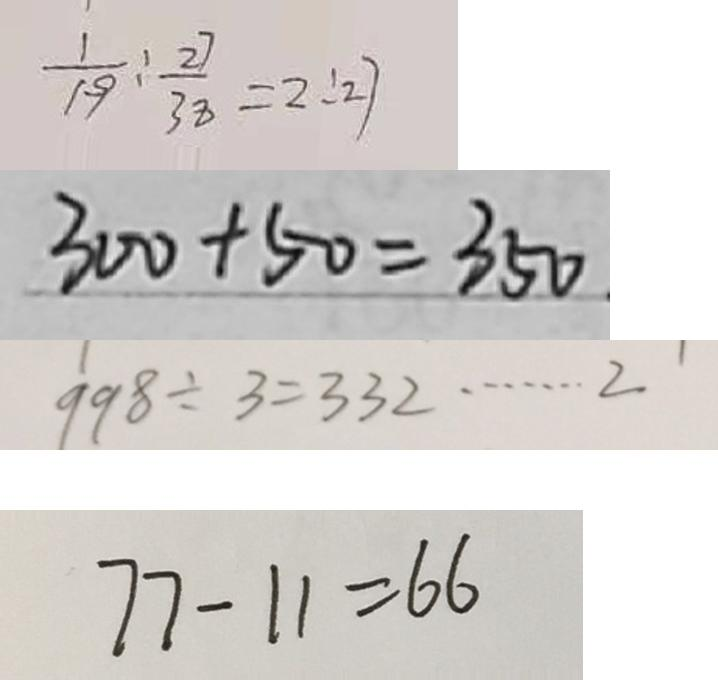<formula> <loc_0><loc_0><loc_500><loc_500>\frac { 1 } { 1 9 } : \frac { 2 7 } { 3 8 } = 2 : 2 7 
 3 0 0 + 5 0 = 3 5 0 . 
 9 9 8 \div 3 = 3 3 2 \cdots 2 
 7 7 - 1 1 = 6 6</formula> 